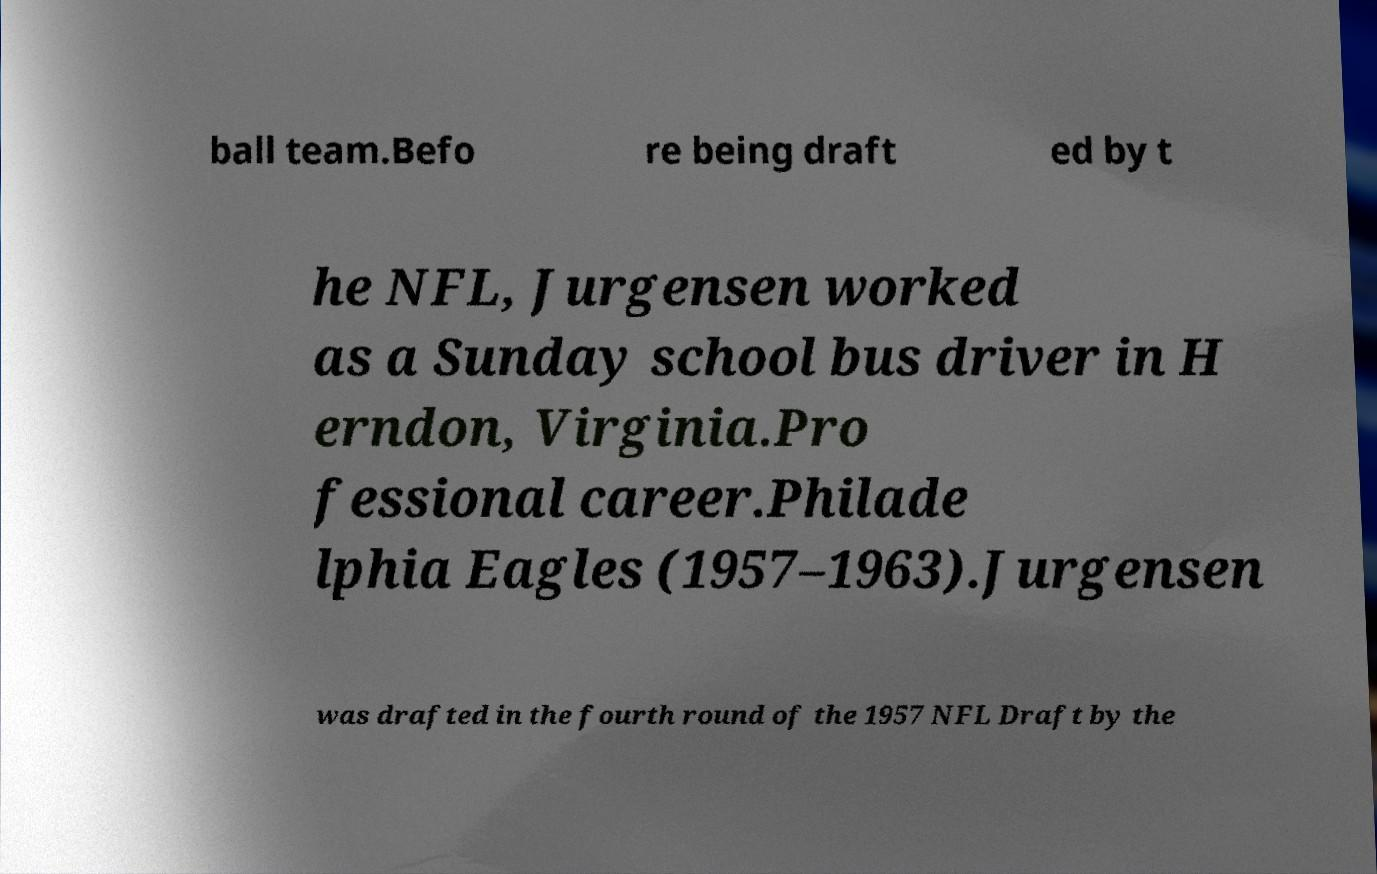For documentation purposes, I need the text within this image transcribed. Could you provide that? ball team.Befo re being draft ed by t he NFL, Jurgensen worked as a Sunday school bus driver in H erndon, Virginia.Pro fessional career.Philade lphia Eagles (1957–1963).Jurgensen was drafted in the fourth round of the 1957 NFL Draft by the 